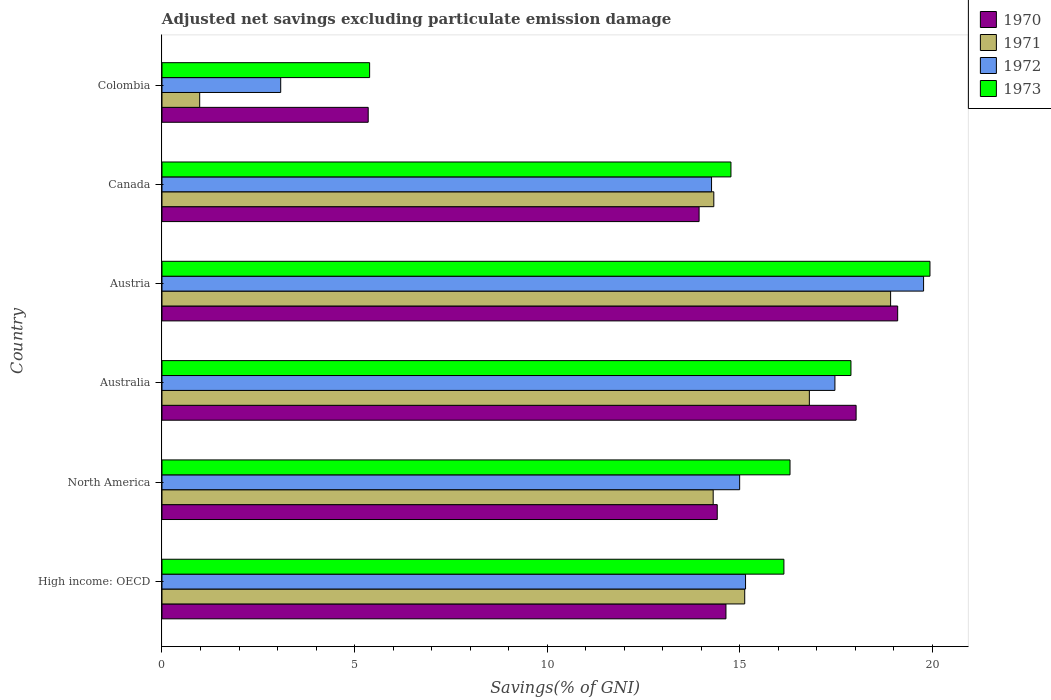How many different coloured bars are there?
Your response must be concise. 4. How many groups of bars are there?
Offer a very short reply. 6. Are the number of bars on each tick of the Y-axis equal?
Your response must be concise. Yes. How many bars are there on the 6th tick from the top?
Your response must be concise. 4. What is the label of the 5th group of bars from the top?
Keep it short and to the point. North America. What is the adjusted net savings in 1971 in Canada?
Your answer should be very brief. 14.33. Across all countries, what is the maximum adjusted net savings in 1972?
Your response must be concise. 19.78. Across all countries, what is the minimum adjusted net savings in 1971?
Your answer should be compact. 0.98. In which country was the adjusted net savings in 1970 maximum?
Your answer should be compact. Austria. In which country was the adjusted net savings in 1971 minimum?
Ensure brevity in your answer.  Colombia. What is the total adjusted net savings in 1970 in the graph?
Your response must be concise. 85.5. What is the difference between the adjusted net savings in 1970 in Canada and that in North America?
Your answer should be compact. -0.47. What is the difference between the adjusted net savings in 1973 in Colombia and the adjusted net savings in 1970 in Canada?
Your response must be concise. -8.56. What is the average adjusted net savings in 1970 per country?
Provide a short and direct response. 14.25. What is the difference between the adjusted net savings in 1971 and adjusted net savings in 1972 in Austria?
Your answer should be very brief. -0.86. What is the ratio of the adjusted net savings in 1972 in Austria to that in Colombia?
Give a very brief answer. 6.42. Is the difference between the adjusted net savings in 1971 in Australia and High income: OECD greater than the difference between the adjusted net savings in 1972 in Australia and High income: OECD?
Ensure brevity in your answer.  No. What is the difference between the highest and the second highest adjusted net savings in 1970?
Ensure brevity in your answer.  1.08. What is the difference between the highest and the lowest adjusted net savings in 1972?
Your answer should be compact. 16.7. Is it the case that in every country, the sum of the adjusted net savings in 1970 and adjusted net savings in 1973 is greater than the sum of adjusted net savings in 1972 and adjusted net savings in 1971?
Your response must be concise. No. What does the 3rd bar from the top in High income: OECD represents?
Your answer should be compact. 1971. What does the 2nd bar from the bottom in Canada represents?
Offer a terse response. 1971. How many bars are there?
Give a very brief answer. 24. How many countries are there in the graph?
Offer a very short reply. 6. Does the graph contain any zero values?
Make the answer very short. No. Where does the legend appear in the graph?
Your answer should be compact. Top right. What is the title of the graph?
Your answer should be very brief. Adjusted net savings excluding particulate emission damage. Does "1960" appear as one of the legend labels in the graph?
Give a very brief answer. No. What is the label or title of the X-axis?
Keep it short and to the point. Savings(% of GNI). What is the Savings(% of GNI) in 1970 in High income: OECD?
Make the answer very short. 14.65. What is the Savings(% of GNI) in 1971 in High income: OECD?
Your answer should be very brief. 15.13. What is the Savings(% of GNI) in 1972 in High income: OECD?
Ensure brevity in your answer.  15.15. What is the Savings(% of GNI) in 1973 in High income: OECD?
Provide a succinct answer. 16.15. What is the Savings(% of GNI) of 1970 in North America?
Offer a very short reply. 14.42. What is the Savings(% of GNI) of 1971 in North America?
Give a very brief answer. 14.31. What is the Savings(% of GNI) of 1972 in North America?
Provide a short and direct response. 15. What is the Savings(% of GNI) in 1973 in North America?
Your answer should be very brief. 16.31. What is the Savings(% of GNI) in 1970 in Australia?
Your answer should be compact. 18.03. What is the Savings(% of GNI) in 1971 in Australia?
Ensure brevity in your answer.  16.81. What is the Savings(% of GNI) of 1972 in Australia?
Provide a short and direct response. 17.48. What is the Savings(% of GNI) in 1973 in Australia?
Offer a terse response. 17.89. What is the Savings(% of GNI) in 1970 in Austria?
Your answer should be compact. 19.11. What is the Savings(% of GNI) of 1971 in Austria?
Offer a terse response. 18.92. What is the Savings(% of GNI) in 1972 in Austria?
Offer a terse response. 19.78. What is the Savings(% of GNI) in 1973 in Austria?
Provide a short and direct response. 19.94. What is the Savings(% of GNI) of 1970 in Canada?
Ensure brevity in your answer.  13.95. What is the Savings(% of GNI) of 1971 in Canada?
Make the answer very short. 14.33. What is the Savings(% of GNI) of 1972 in Canada?
Keep it short and to the point. 14.27. What is the Savings(% of GNI) of 1973 in Canada?
Offer a terse response. 14.78. What is the Savings(% of GNI) of 1970 in Colombia?
Offer a terse response. 5.36. What is the Savings(% of GNI) in 1971 in Colombia?
Give a very brief answer. 0.98. What is the Savings(% of GNI) of 1972 in Colombia?
Your answer should be compact. 3.08. What is the Savings(% of GNI) of 1973 in Colombia?
Provide a short and direct response. 5.39. Across all countries, what is the maximum Savings(% of GNI) in 1970?
Ensure brevity in your answer.  19.11. Across all countries, what is the maximum Savings(% of GNI) of 1971?
Your response must be concise. 18.92. Across all countries, what is the maximum Savings(% of GNI) of 1972?
Make the answer very short. 19.78. Across all countries, what is the maximum Savings(% of GNI) in 1973?
Offer a very short reply. 19.94. Across all countries, what is the minimum Savings(% of GNI) in 1970?
Give a very brief answer. 5.36. Across all countries, what is the minimum Savings(% of GNI) of 1971?
Your answer should be compact. 0.98. Across all countries, what is the minimum Savings(% of GNI) in 1972?
Give a very brief answer. 3.08. Across all countries, what is the minimum Savings(% of GNI) of 1973?
Keep it short and to the point. 5.39. What is the total Savings(% of GNI) in 1970 in the graph?
Offer a terse response. 85.5. What is the total Savings(% of GNI) of 1971 in the graph?
Your answer should be compact. 80.49. What is the total Savings(% of GNI) of 1972 in the graph?
Provide a succinct answer. 84.77. What is the total Savings(% of GNI) of 1973 in the graph?
Your answer should be compact. 90.47. What is the difference between the Savings(% of GNI) in 1970 in High income: OECD and that in North America?
Offer a very short reply. 0.23. What is the difference between the Savings(% of GNI) of 1971 in High income: OECD and that in North America?
Keep it short and to the point. 0.82. What is the difference between the Savings(% of GNI) of 1972 in High income: OECD and that in North America?
Offer a terse response. 0.15. What is the difference between the Savings(% of GNI) in 1973 in High income: OECD and that in North America?
Ensure brevity in your answer.  -0.16. What is the difference between the Savings(% of GNI) of 1970 in High income: OECD and that in Australia?
Provide a short and direct response. -3.38. What is the difference between the Savings(% of GNI) in 1971 in High income: OECD and that in Australia?
Provide a short and direct response. -1.68. What is the difference between the Savings(% of GNI) in 1972 in High income: OECD and that in Australia?
Your answer should be compact. -2.32. What is the difference between the Savings(% of GNI) of 1973 in High income: OECD and that in Australia?
Ensure brevity in your answer.  -1.74. What is the difference between the Savings(% of GNI) in 1970 in High income: OECD and that in Austria?
Your answer should be compact. -4.46. What is the difference between the Savings(% of GNI) of 1971 in High income: OECD and that in Austria?
Offer a very short reply. -3.79. What is the difference between the Savings(% of GNI) of 1972 in High income: OECD and that in Austria?
Offer a very short reply. -4.62. What is the difference between the Savings(% of GNI) of 1973 in High income: OECD and that in Austria?
Make the answer very short. -3.79. What is the difference between the Savings(% of GNI) in 1970 in High income: OECD and that in Canada?
Make the answer very short. 0.7. What is the difference between the Savings(% of GNI) of 1971 in High income: OECD and that in Canada?
Offer a very short reply. 0.8. What is the difference between the Savings(% of GNI) of 1972 in High income: OECD and that in Canada?
Your answer should be very brief. 0.88. What is the difference between the Savings(% of GNI) of 1973 in High income: OECD and that in Canada?
Offer a very short reply. 1.38. What is the difference between the Savings(% of GNI) of 1970 in High income: OECD and that in Colombia?
Provide a succinct answer. 9.29. What is the difference between the Savings(% of GNI) of 1971 in High income: OECD and that in Colombia?
Your response must be concise. 14.15. What is the difference between the Savings(% of GNI) in 1972 in High income: OECD and that in Colombia?
Offer a terse response. 12.07. What is the difference between the Savings(% of GNI) in 1973 in High income: OECD and that in Colombia?
Provide a succinct answer. 10.76. What is the difference between the Savings(% of GNI) of 1970 in North America and that in Australia?
Provide a short and direct response. -3.61. What is the difference between the Savings(% of GNI) of 1971 in North America and that in Australia?
Ensure brevity in your answer.  -2.5. What is the difference between the Savings(% of GNI) in 1972 in North America and that in Australia?
Your answer should be compact. -2.47. What is the difference between the Savings(% of GNI) in 1973 in North America and that in Australia?
Give a very brief answer. -1.58. What is the difference between the Savings(% of GNI) in 1970 in North America and that in Austria?
Keep it short and to the point. -4.69. What is the difference between the Savings(% of GNI) in 1971 in North America and that in Austria?
Offer a terse response. -4.61. What is the difference between the Savings(% of GNI) in 1972 in North America and that in Austria?
Give a very brief answer. -4.78. What is the difference between the Savings(% of GNI) of 1973 in North America and that in Austria?
Offer a very short reply. -3.63. What is the difference between the Savings(% of GNI) of 1970 in North America and that in Canada?
Give a very brief answer. 0.47. What is the difference between the Savings(% of GNI) in 1971 in North America and that in Canada?
Provide a succinct answer. -0.02. What is the difference between the Savings(% of GNI) in 1972 in North America and that in Canada?
Keep it short and to the point. 0.73. What is the difference between the Savings(% of GNI) of 1973 in North America and that in Canada?
Provide a short and direct response. 1.53. What is the difference between the Savings(% of GNI) of 1970 in North America and that in Colombia?
Ensure brevity in your answer.  9.06. What is the difference between the Savings(% of GNI) in 1971 in North America and that in Colombia?
Keep it short and to the point. 13.34. What is the difference between the Savings(% of GNI) of 1972 in North America and that in Colombia?
Keep it short and to the point. 11.92. What is the difference between the Savings(% of GNI) of 1973 in North America and that in Colombia?
Ensure brevity in your answer.  10.92. What is the difference between the Savings(% of GNI) of 1970 in Australia and that in Austria?
Offer a very short reply. -1.08. What is the difference between the Savings(% of GNI) of 1971 in Australia and that in Austria?
Provide a short and direct response. -2.11. What is the difference between the Savings(% of GNI) in 1972 in Australia and that in Austria?
Your answer should be compact. -2.3. What is the difference between the Savings(% of GNI) of 1973 in Australia and that in Austria?
Make the answer very short. -2.05. What is the difference between the Savings(% of GNI) of 1970 in Australia and that in Canada?
Keep it short and to the point. 4.08. What is the difference between the Savings(% of GNI) of 1971 in Australia and that in Canada?
Provide a succinct answer. 2.48. What is the difference between the Savings(% of GNI) of 1972 in Australia and that in Canada?
Your answer should be compact. 3.2. What is the difference between the Savings(% of GNI) of 1973 in Australia and that in Canada?
Make the answer very short. 3.12. What is the difference between the Savings(% of GNI) of 1970 in Australia and that in Colombia?
Your answer should be very brief. 12.67. What is the difference between the Savings(% of GNI) in 1971 in Australia and that in Colombia?
Provide a short and direct response. 15.83. What is the difference between the Savings(% of GNI) in 1972 in Australia and that in Colombia?
Ensure brevity in your answer.  14.39. What is the difference between the Savings(% of GNI) in 1973 in Australia and that in Colombia?
Make the answer very short. 12.5. What is the difference between the Savings(% of GNI) in 1970 in Austria and that in Canada?
Keep it short and to the point. 5.16. What is the difference between the Savings(% of GNI) in 1971 in Austria and that in Canada?
Keep it short and to the point. 4.59. What is the difference between the Savings(% of GNI) of 1972 in Austria and that in Canada?
Your response must be concise. 5.51. What is the difference between the Savings(% of GNI) of 1973 in Austria and that in Canada?
Your answer should be very brief. 5.17. What is the difference between the Savings(% of GNI) in 1970 in Austria and that in Colombia?
Your response must be concise. 13.75. What is the difference between the Savings(% of GNI) of 1971 in Austria and that in Colombia?
Your answer should be compact. 17.94. What is the difference between the Savings(% of GNI) of 1972 in Austria and that in Colombia?
Provide a short and direct response. 16.7. What is the difference between the Savings(% of GNI) of 1973 in Austria and that in Colombia?
Provide a succinct answer. 14.55. What is the difference between the Savings(% of GNI) of 1970 in Canada and that in Colombia?
Give a very brief answer. 8.59. What is the difference between the Savings(% of GNI) in 1971 in Canada and that in Colombia?
Provide a short and direct response. 13.35. What is the difference between the Savings(% of GNI) of 1972 in Canada and that in Colombia?
Keep it short and to the point. 11.19. What is the difference between the Savings(% of GNI) in 1973 in Canada and that in Colombia?
Your answer should be compact. 9.38. What is the difference between the Savings(% of GNI) of 1970 in High income: OECD and the Savings(% of GNI) of 1971 in North America?
Make the answer very short. 0.33. What is the difference between the Savings(% of GNI) of 1970 in High income: OECD and the Savings(% of GNI) of 1972 in North America?
Your answer should be compact. -0.36. What is the difference between the Savings(% of GNI) in 1970 in High income: OECD and the Savings(% of GNI) in 1973 in North America?
Provide a short and direct response. -1.66. What is the difference between the Savings(% of GNI) of 1971 in High income: OECD and the Savings(% of GNI) of 1972 in North America?
Your answer should be very brief. 0.13. What is the difference between the Savings(% of GNI) of 1971 in High income: OECD and the Savings(% of GNI) of 1973 in North America?
Your answer should be very brief. -1.18. What is the difference between the Savings(% of GNI) of 1972 in High income: OECD and the Savings(% of GNI) of 1973 in North America?
Offer a terse response. -1.15. What is the difference between the Savings(% of GNI) in 1970 in High income: OECD and the Savings(% of GNI) in 1971 in Australia?
Make the answer very short. -2.17. What is the difference between the Savings(% of GNI) in 1970 in High income: OECD and the Savings(% of GNI) in 1972 in Australia?
Keep it short and to the point. -2.83. What is the difference between the Savings(% of GNI) in 1970 in High income: OECD and the Savings(% of GNI) in 1973 in Australia?
Ensure brevity in your answer.  -3.25. What is the difference between the Savings(% of GNI) in 1971 in High income: OECD and the Savings(% of GNI) in 1972 in Australia?
Keep it short and to the point. -2.34. What is the difference between the Savings(% of GNI) of 1971 in High income: OECD and the Savings(% of GNI) of 1973 in Australia?
Your answer should be compact. -2.76. What is the difference between the Savings(% of GNI) of 1972 in High income: OECD and the Savings(% of GNI) of 1973 in Australia?
Offer a terse response. -2.74. What is the difference between the Savings(% of GNI) in 1970 in High income: OECD and the Savings(% of GNI) in 1971 in Austria?
Offer a terse response. -4.28. What is the difference between the Savings(% of GNI) of 1970 in High income: OECD and the Savings(% of GNI) of 1972 in Austria?
Your answer should be compact. -5.13. What is the difference between the Savings(% of GNI) of 1970 in High income: OECD and the Savings(% of GNI) of 1973 in Austria?
Provide a succinct answer. -5.3. What is the difference between the Savings(% of GNI) of 1971 in High income: OECD and the Savings(% of GNI) of 1972 in Austria?
Make the answer very short. -4.64. What is the difference between the Savings(% of GNI) in 1971 in High income: OECD and the Savings(% of GNI) in 1973 in Austria?
Provide a short and direct response. -4.81. What is the difference between the Savings(% of GNI) in 1972 in High income: OECD and the Savings(% of GNI) in 1973 in Austria?
Offer a very short reply. -4.79. What is the difference between the Savings(% of GNI) in 1970 in High income: OECD and the Savings(% of GNI) in 1971 in Canada?
Make the answer very short. 0.32. What is the difference between the Savings(% of GNI) of 1970 in High income: OECD and the Savings(% of GNI) of 1972 in Canada?
Give a very brief answer. 0.37. What is the difference between the Savings(% of GNI) of 1970 in High income: OECD and the Savings(% of GNI) of 1973 in Canada?
Offer a very short reply. -0.13. What is the difference between the Savings(% of GNI) of 1971 in High income: OECD and the Savings(% of GNI) of 1972 in Canada?
Provide a short and direct response. 0.86. What is the difference between the Savings(% of GNI) in 1971 in High income: OECD and the Savings(% of GNI) in 1973 in Canada?
Your answer should be very brief. 0.36. What is the difference between the Savings(% of GNI) of 1972 in High income: OECD and the Savings(% of GNI) of 1973 in Canada?
Provide a succinct answer. 0.38. What is the difference between the Savings(% of GNI) in 1970 in High income: OECD and the Savings(% of GNI) in 1971 in Colombia?
Keep it short and to the point. 13.67. What is the difference between the Savings(% of GNI) of 1970 in High income: OECD and the Savings(% of GNI) of 1972 in Colombia?
Your answer should be compact. 11.56. What is the difference between the Savings(% of GNI) of 1970 in High income: OECD and the Savings(% of GNI) of 1973 in Colombia?
Your answer should be compact. 9.25. What is the difference between the Savings(% of GNI) in 1971 in High income: OECD and the Savings(% of GNI) in 1972 in Colombia?
Keep it short and to the point. 12.05. What is the difference between the Savings(% of GNI) in 1971 in High income: OECD and the Savings(% of GNI) in 1973 in Colombia?
Provide a succinct answer. 9.74. What is the difference between the Savings(% of GNI) of 1972 in High income: OECD and the Savings(% of GNI) of 1973 in Colombia?
Provide a succinct answer. 9.76. What is the difference between the Savings(% of GNI) in 1970 in North America and the Savings(% of GNI) in 1971 in Australia?
Give a very brief answer. -2.39. What is the difference between the Savings(% of GNI) in 1970 in North America and the Savings(% of GNI) in 1972 in Australia?
Offer a very short reply. -3.06. What is the difference between the Savings(% of GNI) of 1970 in North America and the Savings(% of GNI) of 1973 in Australia?
Make the answer very short. -3.47. What is the difference between the Savings(% of GNI) of 1971 in North America and the Savings(% of GNI) of 1972 in Australia?
Provide a short and direct response. -3.16. What is the difference between the Savings(% of GNI) of 1971 in North America and the Savings(% of GNI) of 1973 in Australia?
Provide a succinct answer. -3.58. What is the difference between the Savings(% of GNI) of 1972 in North America and the Savings(% of GNI) of 1973 in Australia?
Keep it short and to the point. -2.89. What is the difference between the Savings(% of GNI) of 1970 in North America and the Savings(% of GNI) of 1971 in Austria?
Provide a succinct answer. -4.5. What is the difference between the Savings(% of GNI) in 1970 in North America and the Savings(% of GNI) in 1972 in Austria?
Give a very brief answer. -5.36. What is the difference between the Savings(% of GNI) in 1970 in North America and the Savings(% of GNI) in 1973 in Austria?
Provide a short and direct response. -5.52. What is the difference between the Savings(% of GNI) in 1971 in North America and the Savings(% of GNI) in 1972 in Austria?
Provide a succinct answer. -5.46. What is the difference between the Savings(% of GNI) in 1971 in North America and the Savings(% of GNI) in 1973 in Austria?
Provide a short and direct response. -5.63. What is the difference between the Savings(% of GNI) of 1972 in North America and the Savings(% of GNI) of 1973 in Austria?
Make the answer very short. -4.94. What is the difference between the Savings(% of GNI) of 1970 in North America and the Savings(% of GNI) of 1971 in Canada?
Your answer should be compact. 0.09. What is the difference between the Savings(% of GNI) of 1970 in North America and the Savings(% of GNI) of 1972 in Canada?
Your response must be concise. 0.15. What is the difference between the Savings(% of GNI) of 1970 in North America and the Savings(% of GNI) of 1973 in Canada?
Ensure brevity in your answer.  -0.36. What is the difference between the Savings(% of GNI) in 1971 in North America and the Savings(% of GNI) in 1972 in Canada?
Make the answer very short. 0.04. What is the difference between the Savings(% of GNI) in 1971 in North America and the Savings(% of GNI) in 1973 in Canada?
Your response must be concise. -0.46. What is the difference between the Savings(% of GNI) of 1972 in North America and the Savings(% of GNI) of 1973 in Canada?
Provide a short and direct response. 0.23. What is the difference between the Savings(% of GNI) of 1970 in North America and the Savings(% of GNI) of 1971 in Colombia?
Offer a very short reply. 13.44. What is the difference between the Savings(% of GNI) in 1970 in North America and the Savings(% of GNI) in 1972 in Colombia?
Make the answer very short. 11.34. What is the difference between the Savings(% of GNI) in 1970 in North America and the Savings(% of GNI) in 1973 in Colombia?
Provide a succinct answer. 9.03. What is the difference between the Savings(% of GNI) in 1971 in North America and the Savings(% of GNI) in 1972 in Colombia?
Keep it short and to the point. 11.23. What is the difference between the Savings(% of GNI) of 1971 in North America and the Savings(% of GNI) of 1973 in Colombia?
Offer a terse response. 8.92. What is the difference between the Savings(% of GNI) in 1972 in North America and the Savings(% of GNI) in 1973 in Colombia?
Give a very brief answer. 9.61. What is the difference between the Savings(% of GNI) of 1970 in Australia and the Savings(% of GNI) of 1971 in Austria?
Your answer should be very brief. -0.9. What is the difference between the Savings(% of GNI) in 1970 in Australia and the Savings(% of GNI) in 1972 in Austria?
Provide a succinct answer. -1.75. What is the difference between the Savings(% of GNI) in 1970 in Australia and the Savings(% of GNI) in 1973 in Austria?
Give a very brief answer. -1.92. What is the difference between the Savings(% of GNI) in 1971 in Australia and the Savings(% of GNI) in 1972 in Austria?
Your answer should be compact. -2.97. What is the difference between the Savings(% of GNI) in 1971 in Australia and the Savings(% of GNI) in 1973 in Austria?
Offer a very short reply. -3.13. What is the difference between the Savings(% of GNI) of 1972 in Australia and the Savings(% of GNI) of 1973 in Austria?
Your answer should be compact. -2.47. What is the difference between the Savings(% of GNI) of 1970 in Australia and the Savings(% of GNI) of 1971 in Canada?
Your response must be concise. 3.7. What is the difference between the Savings(% of GNI) in 1970 in Australia and the Savings(% of GNI) in 1972 in Canada?
Make the answer very short. 3.75. What is the difference between the Savings(% of GNI) in 1970 in Australia and the Savings(% of GNI) in 1973 in Canada?
Keep it short and to the point. 3.25. What is the difference between the Savings(% of GNI) of 1971 in Australia and the Savings(% of GNI) of 1972 in Canada?
Offer a very short reply. 2.54. What is the difference between the Savings(% of GNI) of 1971 in Australia and the Savings(% of GNI) of 1973 in Canada?
Give a very brief answer. 2.04. What is the difference between the Savings(% of GNI) in 1970 in Australia and the Savings(% of GNI) in 1971 in Colombia?
Your response must be concise. 17.05. What is the difference between the Savings(% of GNI) of 1970 in Australia and the Savings(% of GNI) of 1972 in Colombia?
Offer a terse response. 14.94. What is the difference between the Savings(% of GNI) of 1970 in Australia and the Savings(% of GNI) of 1973 in Colombia?
Provide a short and direct response. 12.63. What is the difference between the Savings(% of GNI) in 1971 in Australia and the Savings(% of GNI) in 1972 in Colombia?
Make the answer very short. 13.73. What is the difference between the Savings(% of GNI) in 1971 in Australia and the Savings(% of GNI) in 1973 in Colombia?
Provide a succinct answer. 11.42. What is the difference between the Savings(% of GNI) in 1972 in Australia and the Savings(% of GNI) in 1973 in Colombia?
Offer a very short reply. 12.08. What is the difference between the Savings(% of GNI) of 1970 in Austria and the Savings(% of GNI) of 1971 in Canada?
Your answer should be compact. 4.77. What is the difference between the Savings(% of GNI) in 1970 in Austria and the Savings(% of GNI) in 1972 in Canada?
Your answer should be very brief. 4.83. What is the difference between the Savings(% of GNI) in 1970 in Austria and the Savings(% of GNI) in 1973 in Canada?
Give a very brief answer. 4.33. What is the difference between the Savings(% of GNI) in 1971 in Austria and the Savings(% of GNI) in 1972 in Canada?
Ensure brevity in your answer.  4.65. What is the difference between the Savings(% of GNI) in 1971 in Austria and the Savings(% of GNI) in 1973 in Canada?
Provide a succinct answer. 4.15. What is the difference between the Savings(% of GNI) of 1972 in Austria and the Savings(% of GNI) of 1973 in Canada?
Your response must be concise. 5. What is the difference between the Savings(% of GNI) of 1970 in Austria and the Savings(% of GNI) of 1971 in Colombia?
Your answer should be very brief. 18.13. What is the difference between the Savings(% of GNI) of 1970 in Austria and the Savings(% of GNI) of 1972 in Colombia?
Your answer should be compact. 16.02. What is the difference between the Savings(% of GNI) of 1970 in Austria and the Savings(% of GNI) of 1973 in Colombia?
Make the answer very short. 13.71. What is the difference between the Savings(% of GNI) in 1971 in Austria and the Savings(% of GNI) in 1972 in Colombia?
Your answer should be very brief. 15.84. What is the difference between the Savings(% of GNI) of 1971 in Austria and the Savings(% of GNI) of 1973 in Colombia?
Ensure brevity in your answer.  13.53. What is the difference between the Savings(% of GNI) in 1972 in Austria and the Savings(% of GNI) in 1973 in Colombia?
Keep it short and to the point. 14.39. What is the difference between the Savings(% of GNI) in 1970 in Canada and the Savings(% of GNI) in 1971 in Colombia?
Your answer should be compact. 12.97. What is the difference between the Savings(% of GNI) in 1970 in Canada and the Savings(% of GNI) in 1972 in Colombia?
Give a very brief answer. 10.87. What is the difference between the Savings(% of GNI) in 1970 in Canada and the Savings(% of GNI) in 1973 in Colombia?
Make the answer very short. 8.56. What is the difference between the Savings(% of GNI) of 1971 in Canada and the Savings(% of GNI) of 1972 in Colombia?
Your answer should be very brief. 11.25. What is the difference between the Savings(% of GNI) of 1971 in Canada and the Savings(% of GNI) of 1973 in Colombia?
Your answer should be compact. 8.94. What is the difference between the Savings(% of GNI) in 1972 in Canada and the Savings(% of GNI) in 1973 in Colombia?
Offer a terse response. 8.88. What is the average Savings(% of GNI) in 1970 per country?
Give a very brief answer. 14.25. What is the average Savings(% of GNI) of 1971 per country?
Keep it short and to the point. 13.42. What is the average Savings(% of GNI) in 1972 per country?
Your answer should be very brief. 14.13. What is the average Savings(% of GNI) in 1973 per country?
Ensure brevity in your answer.  15.08. What is the difference between the Savings(% of GNI) of 1970 and Savings(% of GNI) of 1971 in High income: OECD?
Keep it short and to the point. -0.49. What is the difference between the Savings(% of GNI) of 1970 and Savings(% of GNI) of 1972 in High income: OECD?
Offer a terse response. -0.51. What is the difference between the Savings(% of GNI) in 1970 and Savings(% of GNI) in 1973 in High income: OECD?
Keep it short and to the point. -1.51. What is the difference between the Savings(% of GNI) of 1971 and Savings(% of GNI) of 1972 in High income: OECD?
Offer a very short reply. -0.02. What is the difference between the Savings(% of GNI) in 1971 and Savings(% of GNI) in 1973 in High income: OECD?
Make the answer very short. -1.02. What is the difference between the Savings(% of GNI) in 1972 and Savings(% of GNI) in 1973 in High income: OECD?
Your response must be concise. -1. What is the difference between the Savings(% of GNI) in 1970 and Savings(% of GNI) in 1971 in North America?
Provide a short and direct response. 0.11. What is the difference between the Savings(% of GNI) in 1970 and Savings(% of GNI) in 1972 in North America?
Provide a short and direct response. -0.58. What is the difference between the Savings(% of GNI) of 1970 and Savings(% of GNI) of 1973 in North America?
Provide a short and direct response. -1.89. What is the difference between the Savings(% of GNI) in 1971 and Savings(% of GNI) in 1972 in North America?
Give a very brief answer. -0.69. What is the difference between the Savings(% of GNI) of 1971 and Savings(% of GNI) of 1973 in North America?
Give a very brief answer. -2. What is the difference between the Savings(% of GNI) of 1972 and Savings(% of GNI) of 1973 in North America?
Your answer should be compact. -1.31. What is the difference between the Savings(% of GNI) of 1970 and Savings(% of GNI) of 1971 in Australia?
Ensure brevity in your answer.  1.21. What is the difference between the Savings(% of GNI) of 1970 and Savings(% of GNI) of 1972 in Australia?
Keep it short and to the point. 0.55. What is the difference between the Savings(% of GNI) in 1970 and Savings(% of GNI) in 1973 in Australia?
Your response must be concise. 0.13. What is the difference between the Savings(% of GNI) in 1971 and Savings(% of GNI) in 1972 in Australia?
Provide a short and direct response. -0.66. What is the difference between the Savings(% of GNI) of 1971 and Savings(% of GNI) of 1973 in Australia?
Give a very brief answer. -1.08. What is the difference between the Savings(% of GNI) in 1972 and Savings(% of GNI) in 1973 in Australia?
Make the answer very short. -0.42. What is the difference between the Savings(% of GNI) of 1970 and Savings(% of GNI) of 1971 in Austria?
Keep it short and to the point. 0.18. What is the difference between the Savings(% of GNI) in 1970 and Savings(% of GNI) in 1972 in Austria?
Ensure brevity in your answer.  -0.67. What is the difference between the Savings(% of GNI) in 1970 and Savings(% of GNI) in 1973 in Austria?
Make the answer very short. -0.84. What is the difference between the Savings(% of GNI) in 1971 and Savings(% of GNI) in 1972 in Austria?
Your answer should be very brief. -0.86. What is the difference between the Savings(% of GNI) of 1971 and Savings(% of GNI) of 1973 in Austria?
Your response must be concise. -1.02. What is the difference between the Savings(% of GNI) of 1972 and Savings(% of GNI) of 1973 in Austria?
Your answer should be compact. -0.17. What is the difference between the Savings(% of GNI) of 1970 and Savings(% of GNI) of 1971 in Canada?
Your answer should be compact. -0.38. What is the difference between the Savings(% of GNI) of 1970 and Savings(% of GNI) of 1972 in Canada?
Ensure brevity in your answer.  -0.32. What is the difference between the Savings(% of GNI) of 1970 and Savings(% of GNI) of 1973 in Canada?
Offer a terse response. -0.83. What is the difference between the Savings(% of GNI) of 1971 and Savings(% of GNI) of 1972 in Canada?
Offer a very short reply. 0.06. What is the difference between the Savings(% of GNI) of 1971 and Savings(% of GNI) of 1973 in Canada?
Offer a terse response. -0.45. What is the difference between the Savings(% of GNI) in 1972 and Savings(% of GNI) in 1973 in Canada?
Your answer should be very brief. -0.5. What is the difference between the Savings(% of GNI) of 1970 and Savings(% of GNI) of 1971 in Colombia?
Make the answer very short. 4.38. What is the difference between the Savings(% of GNI) in 1970 and Savings(% of GNI) in 1972 in Colombia?
Ensure brevity in your answer.  2.27. What is the difference between the Savings(% of GNI) in 1970 and Savings(% of GNI) in 1973 in Colombia?
Keep it short and to the point. -0.04. What is the difference between the Savings(% of GNI) of 1971 and Savings(% of GNI) of 1972 in Colombia?
Your response must be concise. -2.1. What is the difference between the Savings(% of GNI) of 1971 and Savings(% of GNI) of 1973 in Colombia?
Ensure brevity in your answer.  -4.41. What is the difference between the Savings(% of GNI) in 1972 and Savings(% of GNI) in 1973 in Colombia?
Your answer should be very brief. -2.31. What is the ratio of the Savings(% of GNI) in 1970 in High income: OECD to that in North America?
Your answer should be compact. 1.02. What is the ratio of the Savings(% of GNI) in 1971 in High income: OECD to that in North America?
Give a very brief answer. 1.06. What is the ratio of the Savings(% of GNI) in 1972 in High income: OECD to that in North America?
Ensure brevity in your answer.  1.01. What is the ratio of the Savings(% of GNI) in 1973 in High income: OECD to that in North America?
Offer a terse response. 0.99. What is the ratio of the Savings(% of GNI) in 1970 in High income: OECD to that in Australia?
Ensure brevity in your answer.  0.81. What is the ratio of the Savings(% of GNI) in 1971 in High income: OECD to that in Australia?
Offer a very short reply. 0.9. What is the ratio of the Savings(% of GNI) of 1972 in High income: OECD to that in Australia?
Make the answer very short. 0.87. What is the ratio of the Savings(% of GNI) of 1973 in High income: OECD to that in Australia?
Make the answer very short. 0.9. What is the ratio of the Savings(% of GNI) in 1970 in High income: OECD to that in Austria?
Keep it short and to the point. 0.77. What is the ratio of the Savings(% of GNI) of 1971 in High income: OECD to that in Austria?
Provide a short and direct response. 0.8. What is the ratio of the Savings(% of GNI) of 1972 in High income: OECD to that in Austria?
Keep it short and to the point. 0.77. What is the ratio of the Savings(% of GNI) in 1973 in High income: OECD to that in Austria?
Your answer should be compact. 0.81. What is the ratio of the Savings(% of GNI) of 1971 in High income: OECD to that in Canada?
Give a very brief answer. 1.06. What is the ratio of the Savings(% of GNI) in 1972 in High income: OECD to that in Canada?
Your response must be concise. 1.06. What is the ratio of the Savings(% of GNI) in 1973 in High income: OECD to that in Canada?
Offer a terse response. 1.09. What is the ratio of the Savings(% of GNI) in 1970 in High income: OECD to that in Colombia?
Make the answer very short. 2.73. What is the ratio of the Savings(% of GNI) in 1971 in High income: OECD to that in Colombia?
Ensure brevity in your answer.  15.45. What is the ratio of the Savings(% of GNI) of 1972 in High income: OECD to that in Colombia?
Give a very brief answer. 4.92. What is the ratio of the Savings(% of GNI) of 1973 in High income: OECD to that in Colombia?
Keep it short and to the point. 3. What is the ratio of the Savings(% of GNI) in 1970 in North America to that in Australia?
Your response must be concise. 0.8. What is the ratio of the Savings(% of GNI) in 1971 in North America to that in Australia?
Your answer should be compact. 0.85. What is the ratio of the Savings(% of GNI) of 1972 in North America to that in Australia?
Your answer should be compact. 0.86. What is the ratio of the Savings(% of GNI) in 1973 in North America to that in Australia?
Your answer should be compact. 0.91. What is the ratio of the Savings(% of GNI) in 1970 in North America to that in Austria?
Provide a succinct answer. 0.75. What is the ratio of the Savings(% of GNI) in 1971 in North America to that in Austria?
Your answer should be very brief. 0.76. What is the ratio of the Savings(% of GNI) of 1972 in North America to that in Austria?
Make the answer very short. 0.76. What is the ratio of the Savings(% of GNI) of 1973 in North America to that in Austria?
Offer a very short reply. 0.82. What is the ratio of the Savings(% of GNI) in 1970 in North America to that in Canada?
Your answer should be compact. 1.03. What is the ratio of the Savings(% of GNI) of 1971 in North America to that in Canada?
Ensure brevity in your answer.  1. What is the ratio of the Savings(% of GNI) of 1972 in North America to that in Canada?
Give a very brief answer. 1.05. What is the ratio of the Savings(% of GNI) of 1973 in North America to that in Canada?
Make the answer very short. 1.1. What is the ratio of the Savings(% of GNI) of 1970 in North America to that in Colombia?
Provide a succinct answer. 2.69. What is the ratio of the Savings(% of GNI) of 1971 in North America to that in Colombia?
Offer a very short reply. 14.62. What is the ratio of the Savings(% of GNI) in 1972 in North America to that in Colombia?
Provide a succinct answer. 4.87. What is the ratio of the Savings(% of GNI) in 1973 in North America to that in Colombia?
Provide a succinct answer. 3.02. What is the ratio of the Savings(% of GNI) in 1970 in Australia to that in Austria?
Your answer should be very brief. 0.94. What is the ratio of the Savings(% of GNI) of 1971 in Australia to that in Austria?
Ensure brevity in your answer.  0.89. What is the ratio of the Savings(% of GNI) in 1972 in Australia to that in Austria?
Offer a very short reply. 0.88. What is the ratio of the Savings(% of GNI) of 1973 in Australia to that in Austria?
Offer a terse response. 0.9. What is the ratio of the Savings(% of GNI) in 1970 in Australia to that in Canada?
Give a very brief answer. 1.29. What is the ratio of the Savings(% of GNI) of 1971 in Australia to that in Canada?
Provide a short and direct response. 1.17. What is the ratio of the Savings(% of GNI) of 1972 in Australia to that in Canada?
Offer a terse response. 1.22. What is the ratio of the Savings(% of GNI) in 1973 in Australia to that in Canada?
Keep it short and to the point. 1.21. What is the ratio of the Savings(% of GNI) in 1970 in Australia to that in Colombia?
Your answer should be very brief. 3.37. What is the ratio of the Savings(% of GNI) in 1971 in Australia to that in Colombia?
Offer a very short reply. 17.17. What is the ratio of the Savings(% of GNI) in 1972 in Australia to that in Colombia?
Your response must be concise. 5.67. What is the ratio of the Savings(% of GNI) in 1973 in Australia to that in Colombia?
Give a very brief answer. 3.32. What is the ratio of the Savings(% of GNI) of 1970 in Austria to that in Canada?
Your answer should be very brief. 1.37. What is the ratio of the Savings(% of GNI) in 1971 in Austria to that in Canada?
Provide a succinct answer. 1.32. What is the ratio of the Savings(% of GNI) of 1972 in Austria to that in Canada?
Provide a succinct answer. 1.39. What is the ratio of the Savings(% of GNI) in 1973 in Austria to that in Canada?
Your answer should be compact. 1.35. What is the ratio of the Savings(% of GNI) in 1970 in Austria to that in Colombia?
Your answer should be very brief. 3.57. What is the ratio of the Savings(% of GNI) of 1971 in Austria to that in Colombia?
Provide a succinct answer. 19.32. What is the ratio of the Savings(% of GNI) of 1972 in Austria to that in Colombia?
Make the answer very short. 6.42. What is the ratio of the Savings(% of GNI) of 1973 in Austria to that in Colombia?
Ensure brevity in your answer.  3.7. What is the ratio of the Savings(% of GNI) in 1970 in Canada to that in Colombia?
Offer a very short reply. 2.6. What is the ratio of the Savings(% of GNI) in 1971 in Canada to that in Colombia?
Your response must be concise. 14.64. What is the ratio of the Savings(% of GNI) of 1972 in Canada to that in Colombia?
Offer a terse response. 4.63. What is the ratio of the Savings(% of GNI) in 1973 in Canada to that in Colombia?
Provide a succinct answer. 2.74. What is the difference between the highest and the second highest Savings(% of GNI) in 1970?
Give a very brief answer. 1.08. What is the difference between the highest and the second highest Savings(% of GNI) of 1971?
Your answer should be very brief. 2.11. What is the difference between the highest and the second highest Savings(% of GNI) in 1972?
Keep it short and to the point. 2.3. What is the difference between the highest and the second highest Savings(% of GNI) of 1973?
Give a very brief answer. 2.05. What is the difference between the highest and the lowest Savings(% of GNI) of 1970?
Provide a succinct answer. 13.75. What is the difference between the highest and the lowest Savings(% of GNI) of 1971?
Give a very brief answer. 17.94. What is the difference between the highest and the lowest Savings(% of GNI) of 1972?
Offer a very short reply. 16.7. What is the difference between the highest and the lowest Savings(% of GNI) in 1973?
Offer a very short reply. 14.55. 